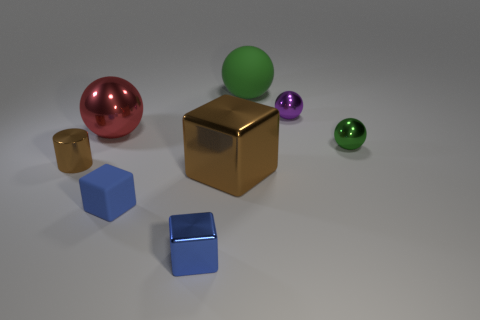Subtract all tiny cubes. How many cubes are left? 1 Add 1 small gray cylinders. How many objects exist? 9 Subtract all blue cubes. How many green balls are left? 2 Subtract all brown cubes. How many cubes are left? 2 Subtract 1 cylinders. How many cylinders are left? 0 Subtract all cubes. How many objects are left? 5 Subtract all brown blocks. Subtract all brown cylinders. How many blocks are left? 2 Subtract all large green spheres. Subtract all purple metallic balls. How many objects are left? 6 Add 4 large green rubber spheres. How many large green rubber spheres are left? 5 Add 4 brown rubber objects. How many brown rubber objects exist? 4 